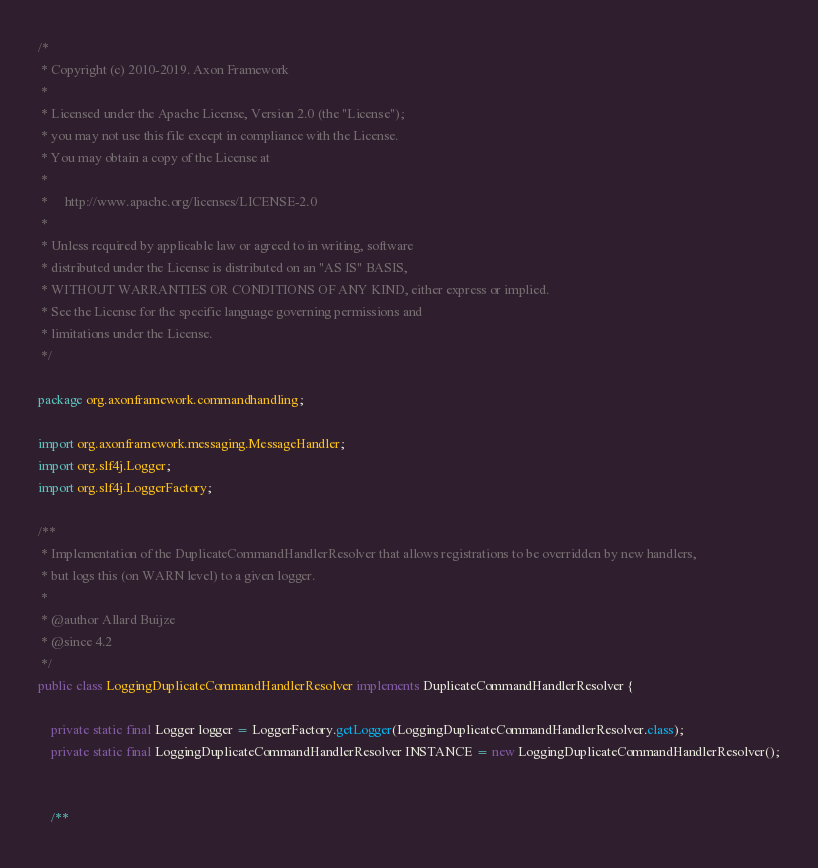Convert code to text. <code><loc_0><loc_0><loc_500><loc_500><_Java_>/*
 * Copyright (c) 2010-2019. Axon Framework
 *
 * Licensed under the Apache License, Version 2.0 (the "License");
 * you may not use this file except in compliance with the License.
 * You may obtain a copy of the License at
 *
 *     http://www.apache.org/licenses/LICENSE-2.0
 *
 * Unless required by applicable law or agreed to in writing, software
 * distributed under the License is distributed on an "AS IS" BASIS,
 * WITHOUT WARRANTIES OR CONDITIONS OF ANY KIND, either express or implied.
 * See the License for the specific language governing permissions and
 * limitations under the License.
 */

package org.axonframework.commandhandling;

import org.axonframework.messaging.MessageHandler;
import org.slf4j.Logger;
import org.slf4j.LoggerFactory;

/**
 * Implementation of the DuplicateCommandHandlerResolver that allows registrations to be overridden by new handlers,
 * but logs this (on WARN level) to a given logger.
 *
 * @author Allard Buijze
 * @since 4.2
 */
public class LoggingDuplicateCommandHandlerResolver implements DuplicateCommandHandlerResolver {

    private static final Logger logger = LoggerFactory.getLogger(LoggingDuplicateCommandHandlerResolver.class);
    private static final LoggingDuplicateCommandHandlerResolver INSTANCE = new LoggingDuplicateCommandHandlerResolver();


    /**</code> 